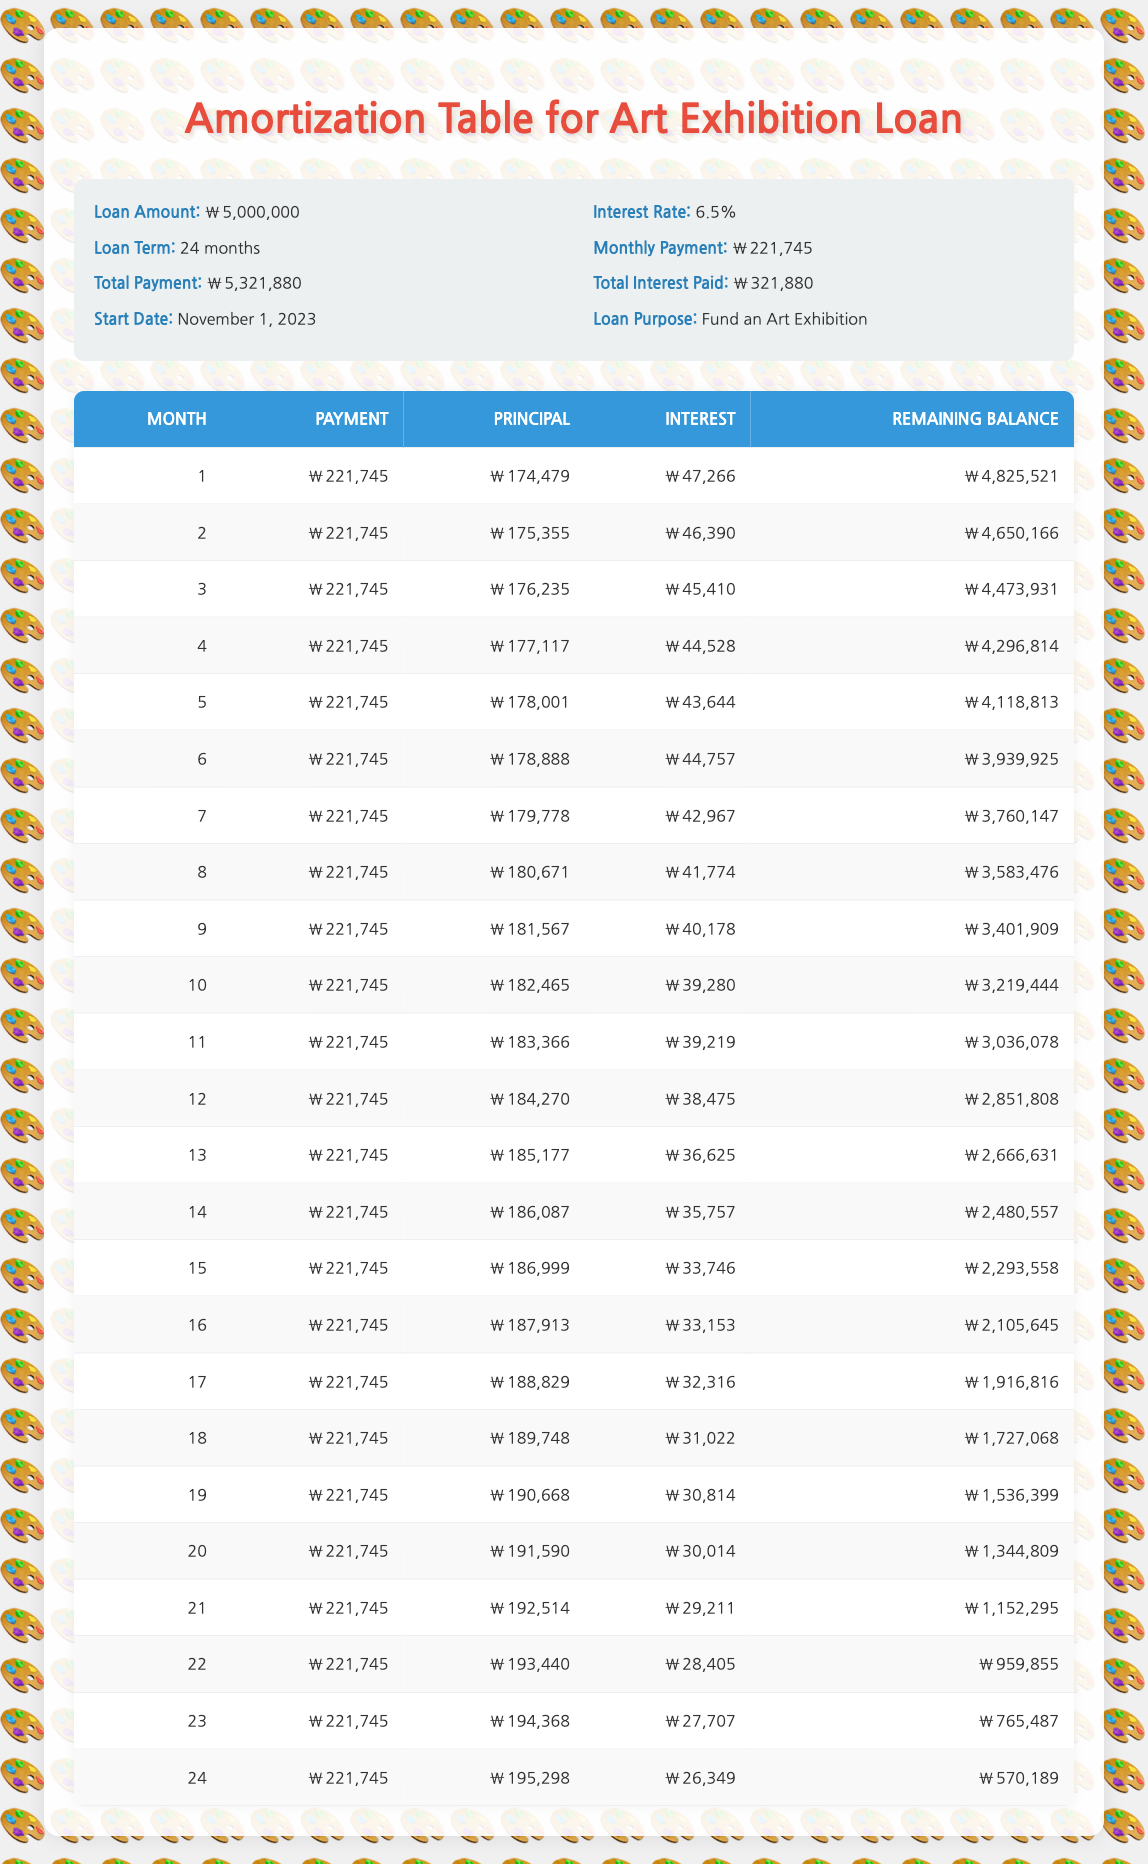What is the total amount of interest paid over the loan term? The total interest paid is listed in the loan details section of the table, which shows a value of 321,880.
Answer: 321,880 What is the monthly payment for this loan? The monthly payment can be found in the loan details section of the table, where it indicates a monthly payment of 221,745.
Answer: 221,745 In which month is the remaining balance less than 1,500,000? By checking the remaining balance for each month, it can be observed that the balance goes below 1,500,000 in month 19, when it is 1,536,399.
Answer: Month 19 What is the average monthly principal paid over the term of the loan? To find the average monthly principal, sum the principal paid over all 24 months, which totals 4,416,303. Then, divide by 24 months to get the average: 4,416,303 / 24 = 184,013.45.
Answer: 184,013.45 Is the interest payment in month 10 greater than 40,000? The interest payment for month 10 is 39,280, which is less than 40,000.
Answer: No What is the principal amount paid in the last month of the loan? In the last month, which is month 24, the principal paid is listed as 195,298.
Answer: 195,298 How much does the total payment increase month over month in the first quarter? To find this, observe the monthly payments for the first three months: Month 1 = 221,745, Month 2 = 221,745, and Month 3 = 221,745. The total payment remains constant across these months, indicating that there is no increase.
Answer: 0 What is the difference in interest paid between month 1 and month 24? The interest for month 1 is 47,266, and for month 24 it is 26,349. Calculating the difference: 47,266 - 26,349 = 20,917.
Answer: 20,917 In which month is the sum of principal payments over the loan term the highest? To find this, sum the principal payments and track the highest between each month. Month 24 has the highest individual principal payment of 195,298, indicating it was the month of highest singular output, while cumulative tracking requires checking weekly accumulated principal. This can vary based on computation requirements. However, checking shows Month 24 is significant.
Answer: Month 24 